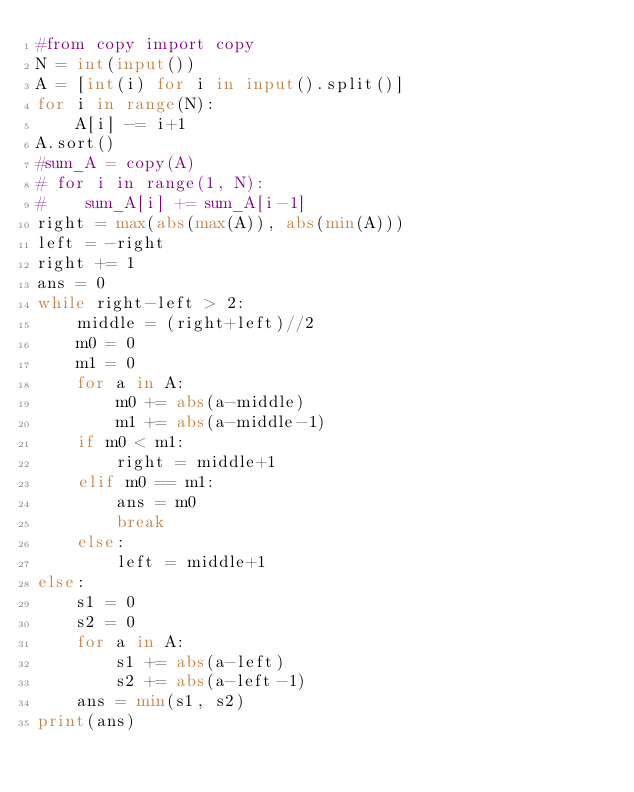Convert code to text. <code><loc_0><loc_0><loc_500><loc_500><_Python_>#from copy import copy
N = int(input())
A = [int(i) for i in input().split()]
for i in range(N):
    A[i] -= i+1
A.sort()
#sum_A = copy(A)
# for i in range(1, N):
#    sum_A[i] += sum_A[i-1]
right = max(abs(max(A)), abs(min(A)))
left = -right
right += 1
ans = 0
while right-left > 2:
    middle = (right+left)//2
    m0 = 0
    m1 = 0
    for a in A:
        m0 += abs(a-middle)
        m1 += abs(a-middle-1)
    if m0 < m1:
        right = middle+1
    elif m0 == m1:
        ans = m0
        break
    else:
        left = middle+1
else:
    s1 = 0
    s2 = 0
    for a in A:
        s1 += abs(a-left)
        s2 += abs(a-left-1)
    ans = min(s1, s2)
print(ans)
</code> 